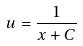<formula> <loc_0><loc_0><loc_500><loc_500>u = \frac { 1 } { x + C }</formula> 